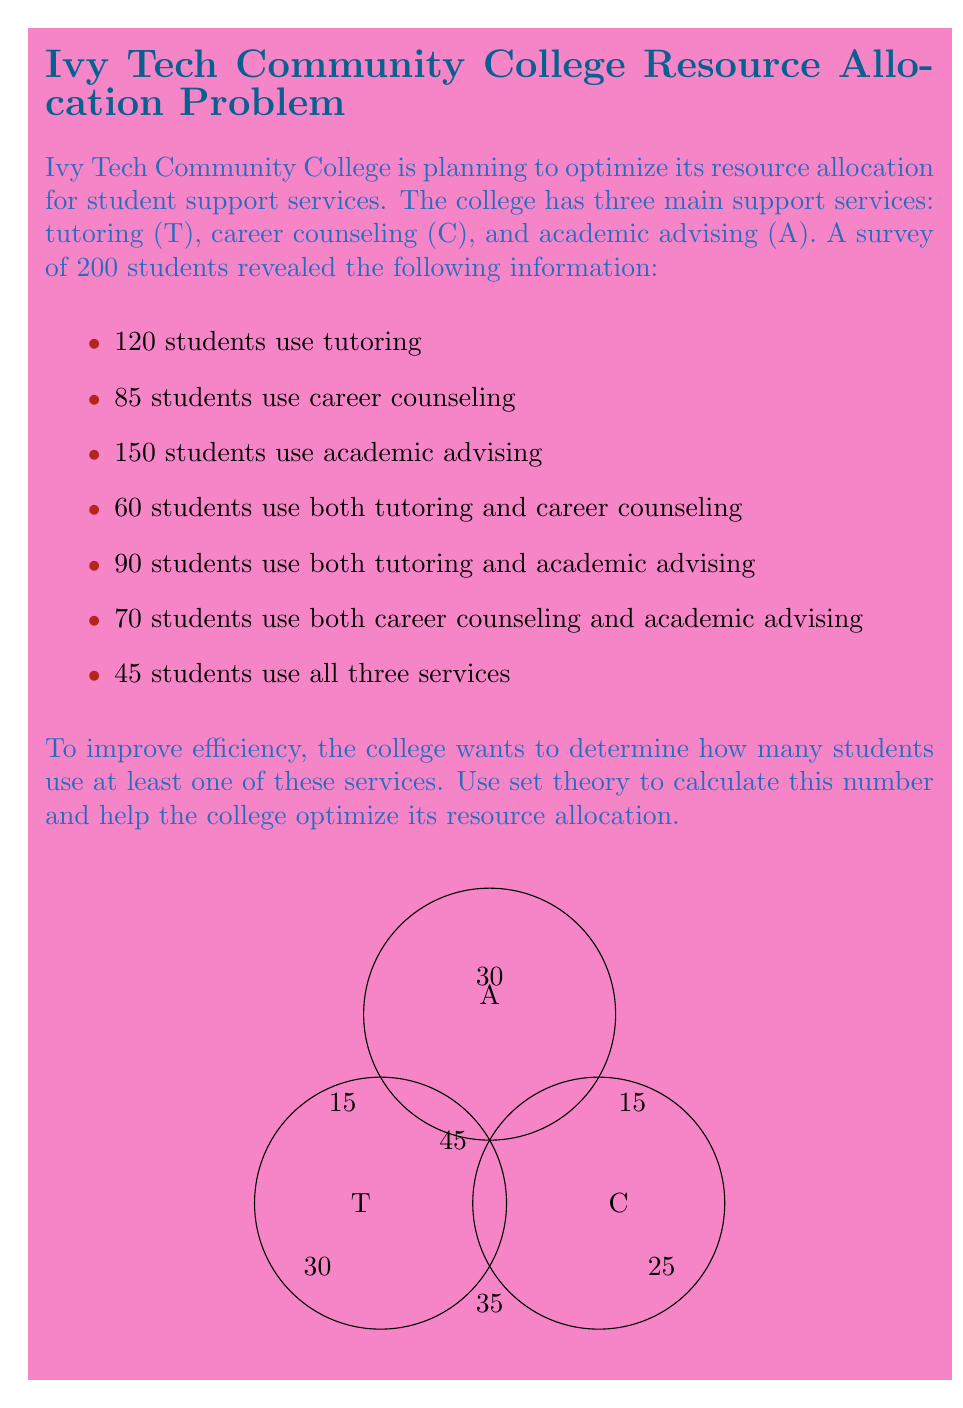Could you help me with this problem? Let's solve this problem step by step using set theory:

1) First, we need to understand what the question is asking. We want to find the number of students who use at least one of the three services. In set theory, this is the union of all three sets: $T \cup C \cup A$.

2) We can use the principle of inclusion-exclusion to solve this problem:

   $|T \cup C \cup A| = |T| + |C| + |A| - |T \cap C| - |T \cap A| - |C \cap A| + |T \cap C \cap A|$

3) We know the following:
   $|T| = 120$
   $|C| = 85$
   $|A| = 150$
   $|T \cap C| = 60$
   $|T \cap A| = 90$
   $|C \cap A| = 70$
   $|T \cap C \cap A| = 45$

4) Now, let's substitute these values into our equation:

   $|T \cup C \cup A| = 120 + 85 + 150 - 60 - 90 - 70 + 45$

5) Simplify:
   $|T \cup C \cup A| = 355 - 220 + 45 = 180$

Therefore, 180 students use at least one of the three services.
Answer: 180 students 